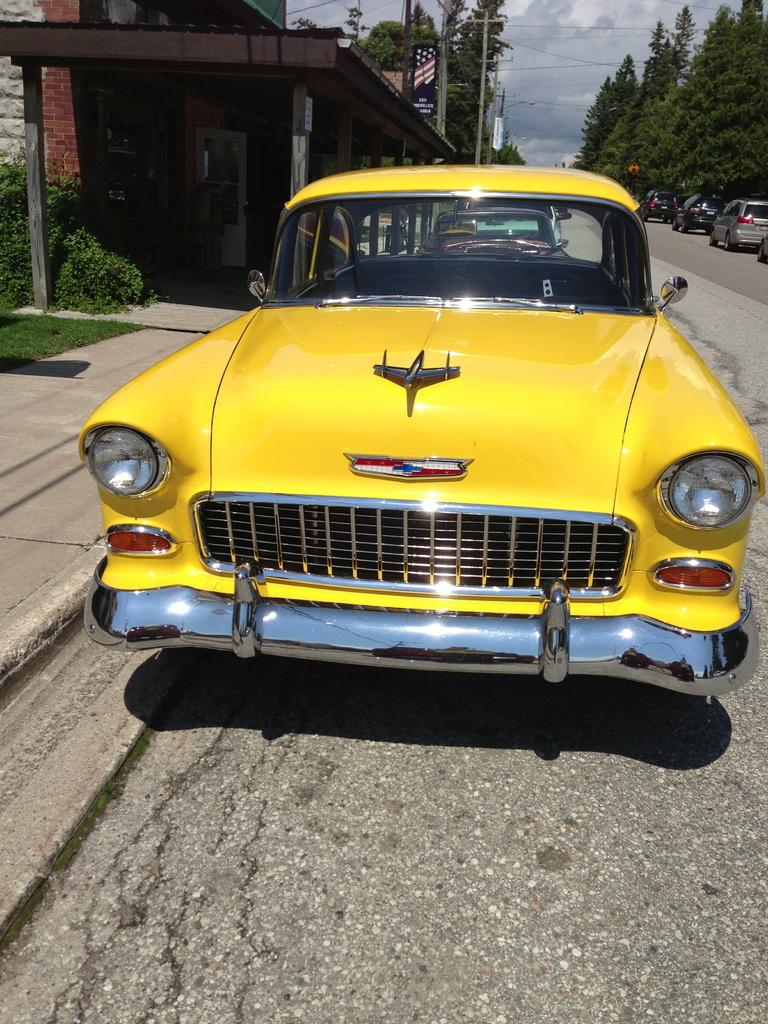What can be seen moving on the road in the image? There are motor vehicles on the road in the image. What is visible in the sky in the image? The sky is visible with clouds in the image. What structures are present in the image that support electrical cables? Electric poles are in the image, and electric cables are present. What type of structures can be seen in the image? There are buildings in the image. What type of vegetation is visible in the image? Grass, shrubs, and trees are visible in the image. Where is the meeting taking place in the image? There is no meeting present in the image. What type of screw is being used to hold the electric cables in the image? There are no screws visible in the image; only electric poles and cables are present. 